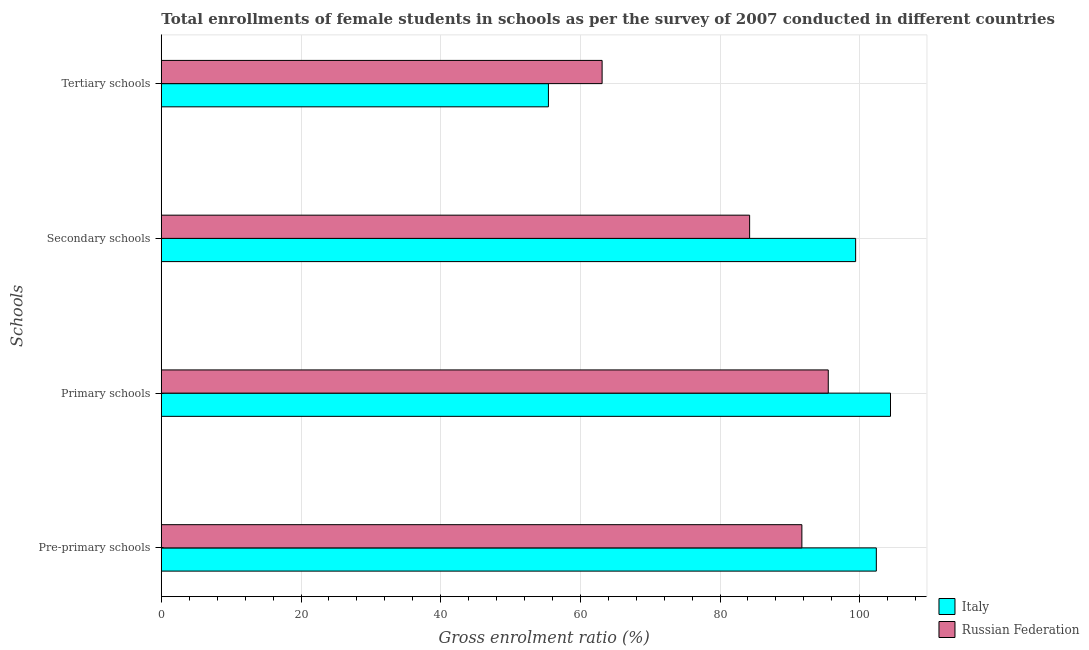How many groups of bars are there?
Ensure brevity in your answer.  4. Are the number of bars on each tick of the Y-axis equal?
Offer a very short reply. Yes. How many bars are there on the 1st tick from the top?
Keep it short and to the point. 2. How many bars are there on the 2nd tick from the bottom?
Your answer should be compact. 2. What is the label of the 1st group of bars from the top?
Your answer should be very brief. Tertiary schools. What is the gross enrolment ratio(female) in tertiary schools in Italy?
Keep it short and to the point. 55.43. Across all countries, what is the maximum gross enrolment ratio(female) in tertiary schools?
Give a very brief answer. 63.12. Across all countries, what is the minimum gross enrolment ratio(female) in pre-primary schools?
Provide a succinct answer. 91.72. In which country was the gross enrolment ratio(female) in tertiary schools maximum?
Offer a terse response. Russian Federation. In which country was the gross enrolment ratio(female) in primary schools minimum?
Offer a very short reply. Russian Federation. What is the total gross enrolment ratio(female) in secondary schools in the graph?
Your response must be concise. 183.65. What is the difference between the gross enrolment ratio(female) in tertiary schools in Italy and that in Russian Federation?
Provide a succinct answer. -7.69. What is the difference between the gross enrolment ratio(female) in tertiary schools in Russian Federation and the gross enrolment ratio(female) in pre-primary schools in Italy?
Ensure brevity in your answer.  -39.26. What is the average gross enrolment ratio(female) in tertiary schools per country?
Ensure brevity in your answer.  59.27. What is the difference between the gross enrolment ratio(female) in primary schools and gross enrolment ratio(female) in pre-primary schools in Russian Federation?
Make the answer very short. 3.78. In how many countries, is the gross enrolment ratio(female) in primary schools greater than 100 %?
Your response must be concise. 1. What is the ratio of the gross enrolment ratio(female) in pre-primary schools in Russian Federation to that in Italy?
Your answer should be very brief. 0.9. Is the gross enrolment ratio(female) in secondary schools in Russian Federation less than that in Italy?
Give a very brief answer. Yes. What is the difference between the highest and the second highest gross enrolment ratio(female) in primary schools?
Your response must be concise. 8.91. What is the difference between the highest and the lowest gross enrolment ratio(female) in primary schools?
Your answer should be compact. 8.91. In how many countries, is the gross enrolment ratio(female) in tertiary schools greater than the average gross enrolment ratio(female) in tertiary schools taken over all countries?
Offer a terse response. 1. Is the sum of the gross enrolment ratio(female) in pre-primary schools in Italy and Russian Federation greater than the maximum gross enrolment ratio(female) in secondary schools across all countries?
Offer a terse response. Yes. What does the 2nd bar from the bottom in Pre-primary schools represents?
Offer a very short reply. Russian Federation. Is it the case that in every country, the sum of the gross enrolment ratio(female) in pre-primary schools and gross enrolment ratio(female) in primary schools is greater than the gross enrolment ratio(female) in secondary schools?
Make the answer very short. Yes. How many countries are there in the graph?
Ensure brevity in your answer.  2. Does the graph contain any zero values?
Give a very brief answer. No. How many legend labels are there?
Ensure brevity in your answer.  2. How are the legend labels stacked?
Make the answer very short. Vertical. What is the title of the graph?
Provide a short and direct response. Total enrollments of female students in schools as per the survey of 2007 conducted in different countries. Does "Vietnam" appear as one of the legend labels in the graph?
Provide a short and direct response. No. What is the label or title of the X-axis?
Keep it short and to the point. Gross enrolment ratio (%). What is the label or title of the Y-axis?
Offer a very short reply. Schools. What is the Gross enrolment ratio (%) in Italy in Pre-primary schools?
Provide a succinct answer. 102.38. What is the Gross enrolment ratio (%) of Russian Federation in Pre-primary schools?
Offer a terse response. 91.72. What is the Gross enrolment ratio (%) of Italy in Primary schools?
Your answer should be compact. 104.41. What is the Gross enrolment ratio (%) of Russian Federation in Primary schools?
Keep it short and to the point. 95.5. What is the Gross enrolment ratio (%) of Italy in Secondary schools?
Give a very brief answer. 99.42. What is the Gross enrolment ratio (%) of Russian Federation in Secondary schools?
Offer a very short reply. 84.24. What is the Gross enrolment ratio (%) of Italy in Tertiary schools?
Give a very brief answer. 55.43. What is the Gross enrolment ratio (%) in Russian Federation in Tertiary schools?
Give a very brief answer. 63.12. Across all Schools, what is the maximum Gross enrolment ratio (%) in Italy?
Your answer should be compact. 104.41. Across all Schools, what is the maximum Gross enrolment ratio (%) of Russian Federation?
Provide a succinct answer. 95.5. Across all Schools, what is the minimum Gross enrolment ratio (%) in Italy?
Your answer should be compact. 55.43. Across all Schools, what is the minimum Gross enrolment ratio (%) in Russian Federation?
Your answer should be compact. 63.12. What is the total Gross enrolment ratio (%) in Italy in the graph?
Your answer should be very brief. 361.63. What is the total Gross enrolment ratio (%) of Russian Federation in the graph?
Your answer should be very brief. 334.57. What is the difference between the Gross enrolment ratio (%) of Italy in Pre-primary schools and that in Primary schools?
Your response must be concise. -2.03. What is the difference between the Gross enrolment ratio (%) in Russian Federation in Pre-primary schools and that in Primary schools?
Provide a short and direct response. -3.78. What is the difference between the Gross enrolment ratio (%) of Italy in Pre-primary schools and that in Secondary schools?
Make the answer very short. 2.96. What is the difference between the Gross enrolment ratio (%) in Russian Federation in Pre-primary schools and that in Secondary schools?
Offer a terse response. 7.48. What is the difference between the Gross enrolment ratio (%) of Italy in Pre-primary schools and that in Tertiary schools?
Keep it short and to the point. 46.95. What is the difference between the Gross enrolment ratio (%) of Russian Federation in Pre-primary schools and that in Tertiary schools?
Provide a succinct answer. 28.6. What is the difference between the Gross enrolment ratio (%) of Italy in Primary schools and that in Secondary schools?
Keep it short and to the point. 4.99. What is the difference between the Gross enrolment ratio (%) in Russian Federation in Primary schools and that in Secondary schools?
Provide a short and direct response. 11.26. What is the difference between the Gross enrolment ratio (%) of Italy in Primary schools and that in Tertiary schools?
Offer a terse response. 48.98. What is the difference between the Gross enrolment ratio (%) of Russian Federation in Primary schools and that in Tertiary schools?
Your answer should be very brief. 32.38. What is the difference between the Gross enrolment ratio (%) in Italy in Secondary schools and that in Tertiary schools?
Give a very brief answer. 43.99. What is the difference between the Gross enrolment ratio (%) of Russian Federation in Secondary schools and that in Tertiary schools?
Your answer should be very brief. 21.12. What is the difference between the Gross enrolment ratio (%) in Italy in Pre-primary schools and the Gross enrolment ratio (%) in Russian Federation in Primary schools?
Provide a succinct answer. 6.88. What is the difference between the Gross enrolment ratio (%) in Italy in Pre-primary schools and the Gross enrolment ratio (%) in Russian Federation in Secondary schools?
Provide a short and direct response. 18.14. What is the difference between the Gross enrolment ratio (%) of Italy in Pre-primary schools and the Gross enrolment ratio (%) of Russian Federation in Tertiary schools?
Provide a short and direct response. 39.26. What is the difference between the Gross enrolment ratio (%) in Italy in Primary schools and the Gross enrolment ratio (%) in Russian Federation in Secondary schools?
Your answer should be very brief. 20.17. What is the difference between the Gross enrolment ratio (%) in Italy in Primary schools and the Gross enrolment ratio (%) in Russian Federation in Tertiary schools?
Your answer should be compact. 41.29. What is the difference between the Gross enrolment ratio (%) of Italy in Secondary schools and the Gross enrolment ratio (%) of Russian Federation in Tertiary schools?
Give a very brief answer. 36.3. What is the average Gross enrolment ratio (%) in Italy per Schools?
Your answer should be very brief. 90.41. What is the average Gross enrolment ratio (%) in Russian Federation per Schools?
Provide a short and direct response. 83.64. What is the difference between the Gross enrolment ratio (%) of Italy and Gross enrolment ratio (%) of Russian Federation in Pre-primary schools?
Provide a succinct answer. 10.66. What is the difference between the Gross enrolment ratio (%) in Italy and Gross enrolment ratio (%) in Russian Federation in Primary schools?
Provide a succinct answer. 8.91. What is the difference between the Gross enrolment ratio (%) of Italy and Gross enrolment ratio (%) of Russian Federation in Secondary schools?
Your answer should be compact. 15.18. What is the difference between the Gross enrolment ratio (%) of Italy and Gross enrolment ratio (%) of Russian Federation in Tertiary schools?
Provide a succinct answer. -7.69. What is the ratio of the Gross enrolment ratio (%) of Italy in Pre-primary schools to that in Primary schools?
Provide a short and direct response. 0.98. What is the ratio of the Gross enrolment ratio (%) in Russian Federation in Pre-primary schools to that in Primary schools?
Give a very brief answer. 0.96. What is the ratio of the Gross enrolment ratio (%) of Italy in Pre-primary schools to that in Secondary schools?
Your answer should be compact. 1.03. What is the ratio of the Gross enrolment ratio (%) of Russian Federation in Pre-primary schools to that in Secondary schools?
Offer a terse response. 1.09. What is the ratio of the Gross enrolment ratio (%) in Italy in Pre-primary schools to that in Tertiary schools?
Your response must be concise. 1.85. What is the ratio of the Gross enrolment ratio (%) of Russian Federation in Pre-primary schools to that in Tertiary schools?
Offer a very short reply. 1.45. What is the ratio of the Gross enrolment ratio (%) in Italy in Primary schools to that in Secondary schools?
Ensure brevity in your answer.  1.05. What is the ratio of the Gross enrolment ratio (%) in Russian Federation in Primary schools to that in Secondary schools?
Keep it short and to the point. 1.13. What is the ratio of the Gross enrolment ratio (%) of Italy in Primary schools to that in Tertiary schools?
Offer a very short reply. 1.88. What is the ratio of the Gross enrolment ratio (%) in Russian Federation in Primary schools to that in Tertiary schools?
Your answer should be very brief. 1.51. What is the ratio of the Gross enrolment ratio (%) in Italy in Secondary schools to that in Tertiary schools?
Provide a succinct answer. 1.79. What is the ratio of the Gross enrolment ratio (%) in Russian Federation in Secondary schools to that in Tertiary schools?
Provide a succinct answer. 1.33. What is the difference between the highest and the second highest Gross enrolment ratio (%) in Italy?
Give a very brief answer. 2.03. What is the difference between the highest and the second highest Gross enrolment ratio (%) in Russian Federation?
Make the answer very short. 3.78. What is the difference between the highest and the lowest Gross enrolment ratio (%) of Italy?
Your answer should be very brief. 48.98. What is the difference between the highest and the lowest Gross enrolment ratio (%) of Russian Federation?
Your answer should be very brief. 32.38. 